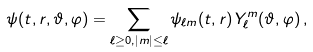<formula> <loc_0><loc_0><loc_500><loc_500>\psi ( t , r , \vartheta , \varphi ) = \sum _ { \ell \geq 0 , | m | \leq \ell } \psi _ { \ell m } ( t , r ) \, Y ^ { m } _ { \ell } ( \vartheta , \varphi ) \, ,</formula> 